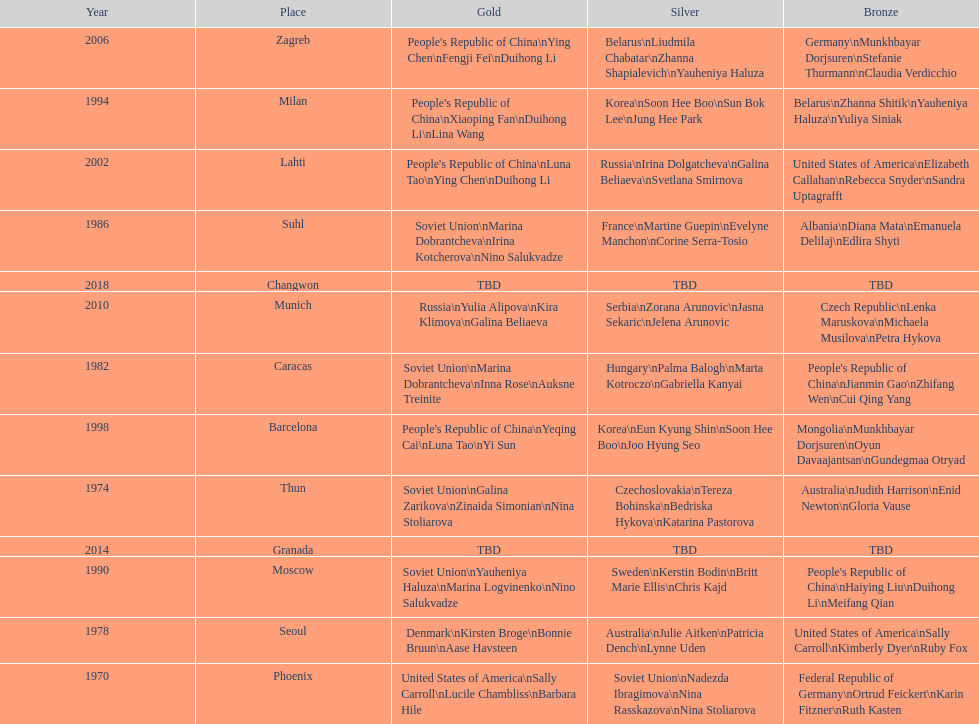How many times has germany won bronze? 2. 